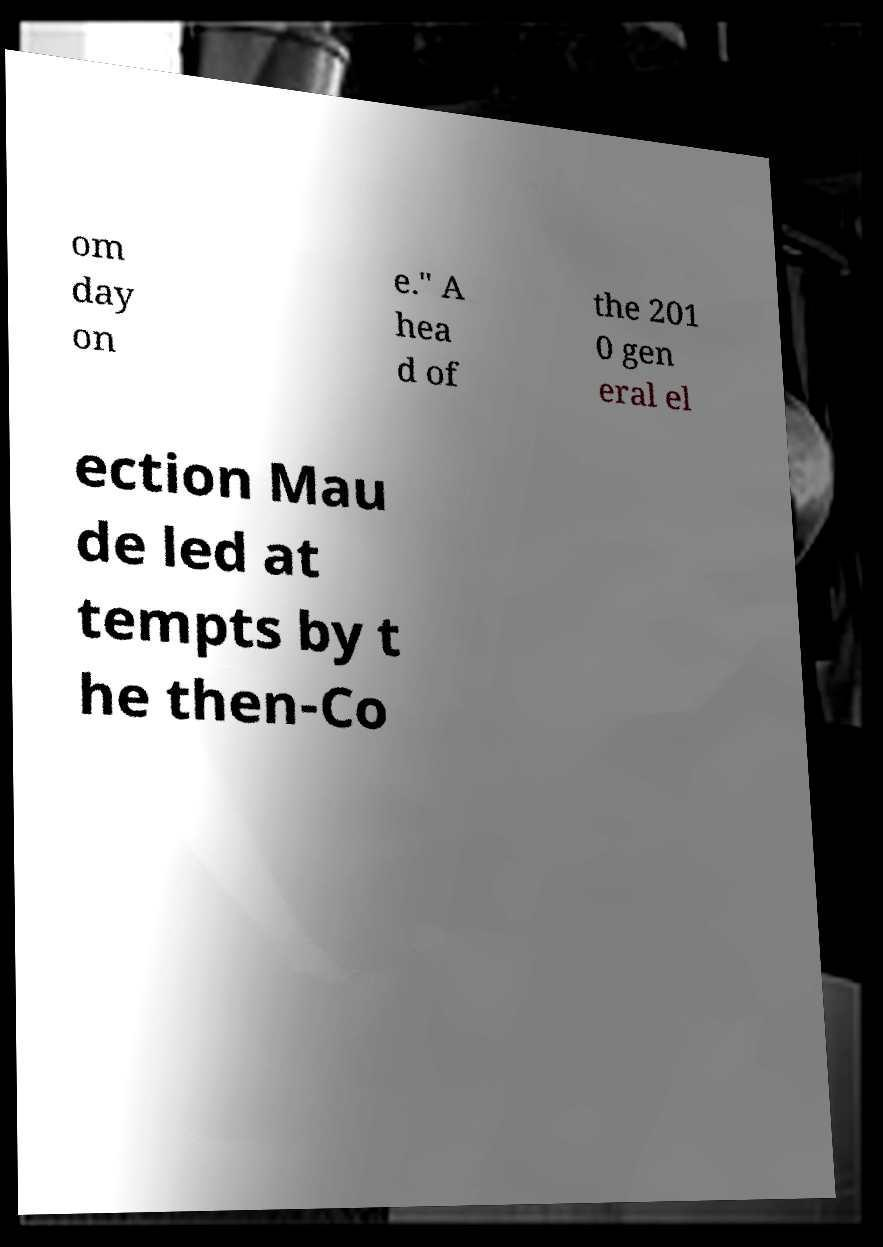For documentation purposes, I need the text within this image transcribed. Could you provide that? om day on e." A hea d of the 201 0 gen eral el ection Mau de led at tempts by t he then-Co 